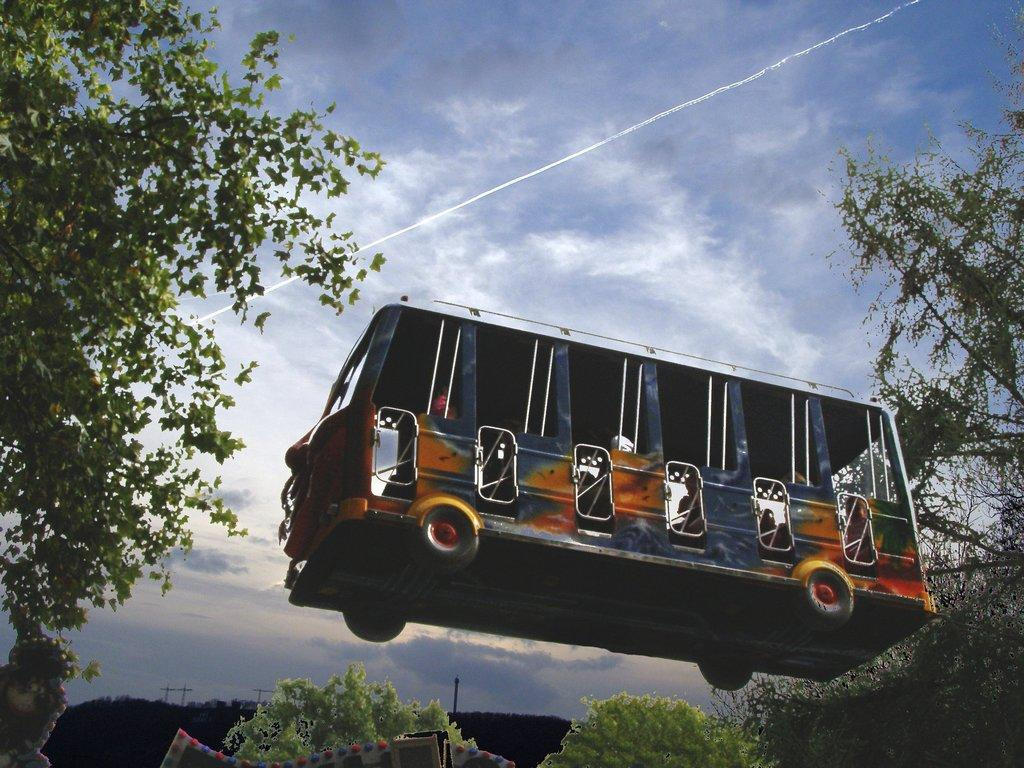What type of image is being shown? The image is an edited picture. What is the main subject in the image? There is a bus in the air in the middle of the image. What can be seen at the bottom of the image? There are trees at the bottom of the image. What is visible in the background of the image? The sky is visible in the background of the image. What else is present in the image besides the bus and trees? There are poles present in the image. How many layers of cake can be seen in the image? There are no cakes present in the image, so it is not possible to determine the number of layers. 